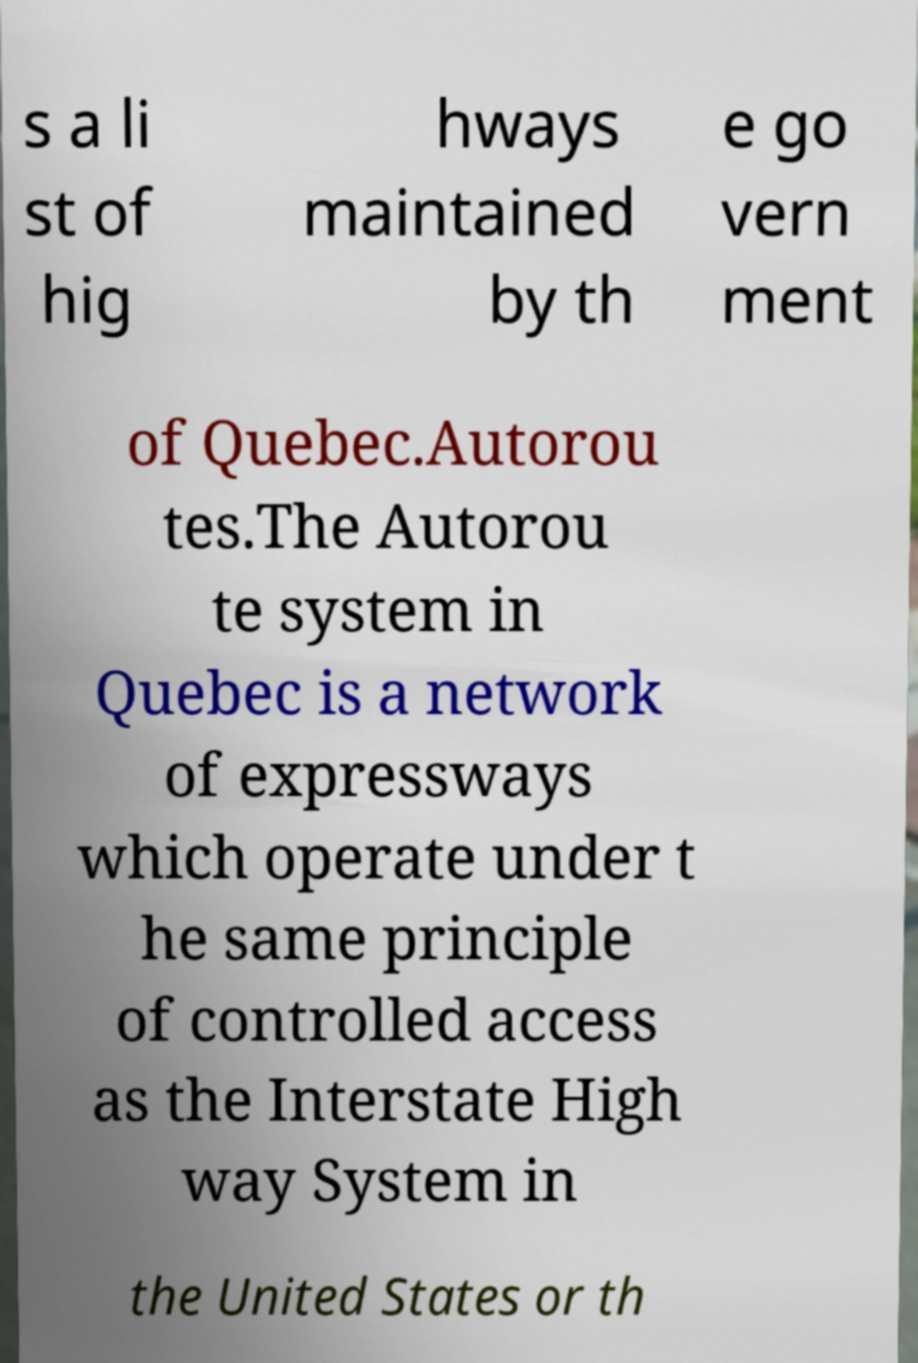Please identify and transcribe the text found in this image. s a li st of hig hways maintained by th e go vern ment of Quebec.Autorou tes.The Autorou te system in Quebec is a network of expressways which operate under t he same principle of controlled access as the Interstate High way System in the United States or th 